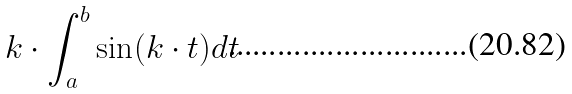Convert formula to latex. <formula><loc_0><loc_0><loc_500><loc_500>k \cdot \int _ { a } ^ { b } \sin ( k \cdot t ) d t</formula> 